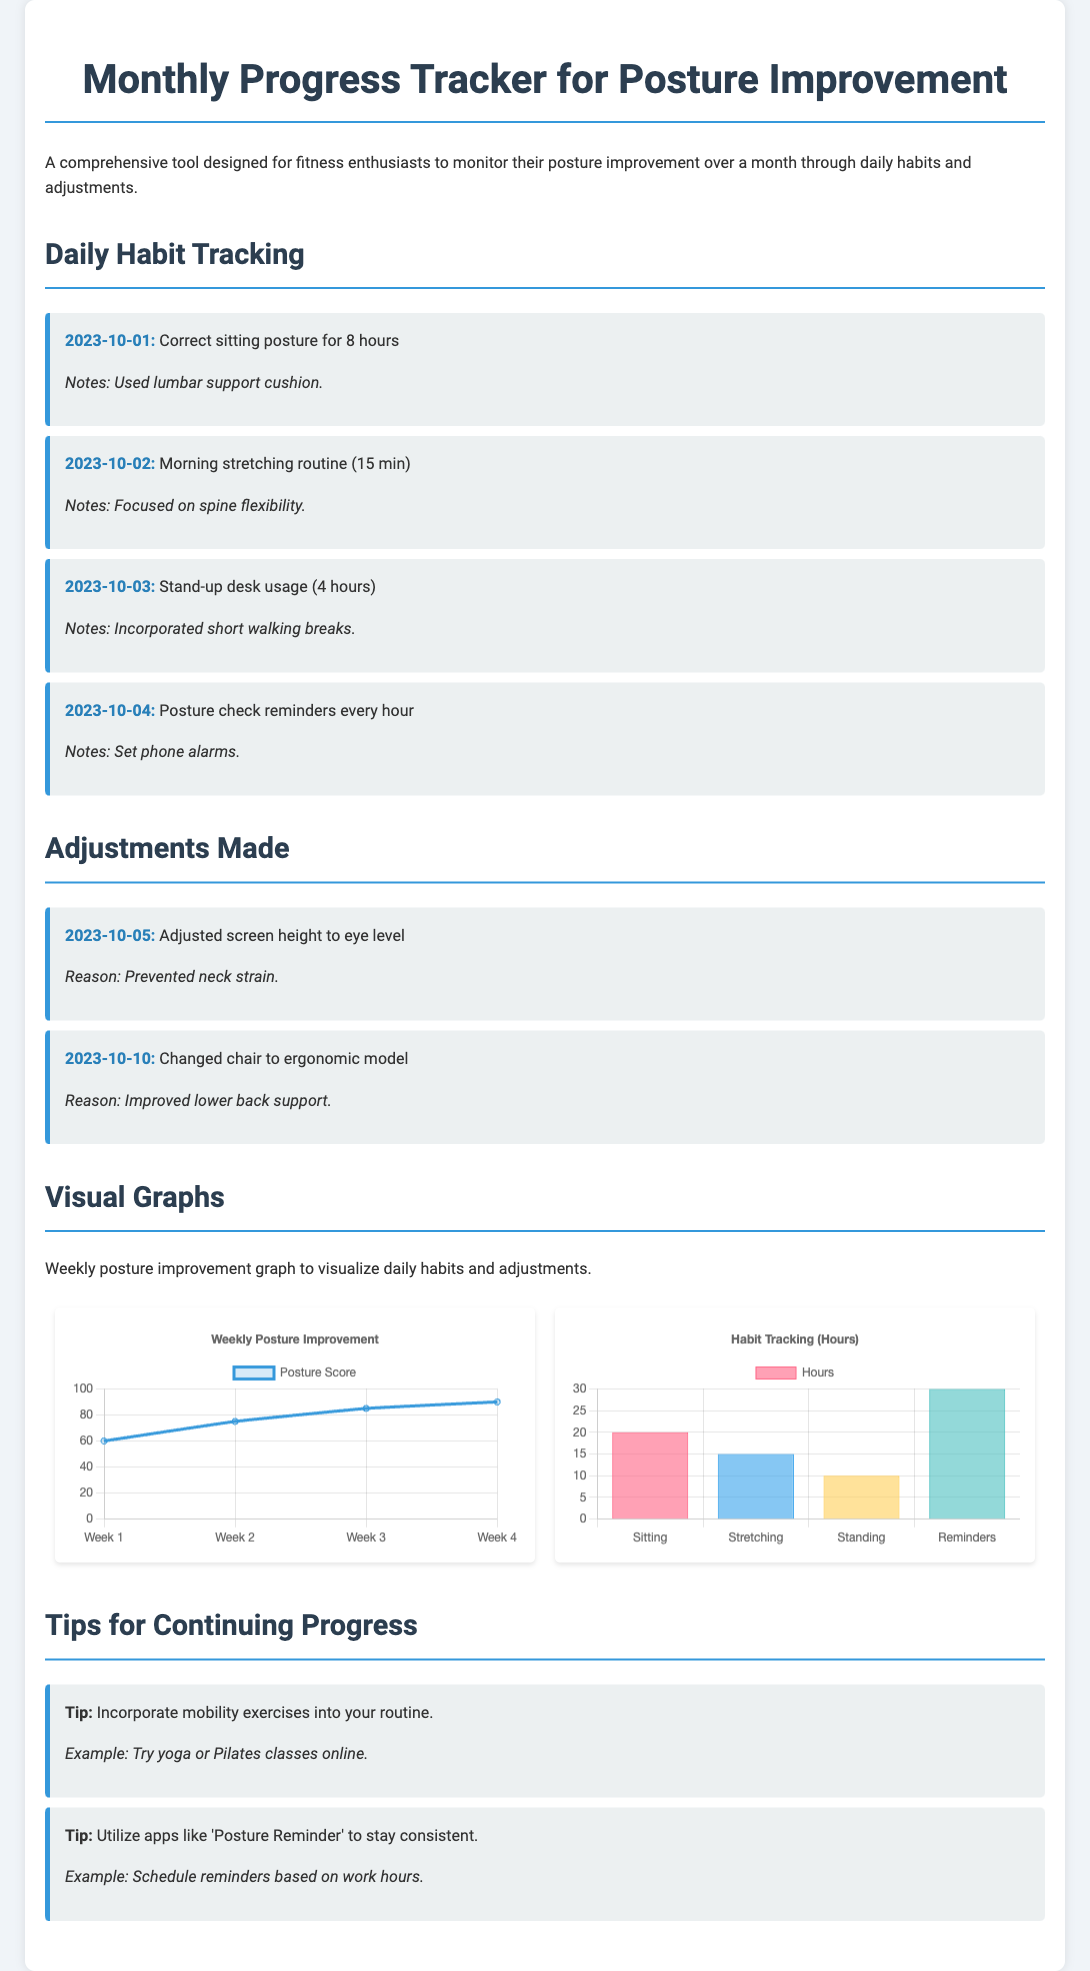what is the title of the document? The title of the document is found at the top, indicating its purpose.
Answer: Monthly Progress Tracker for Posture Improvement how many weeks are displayed in the posture improvement graph? The graph displays data for posture improvement over a specific duration.
Answer: 4 what date is the first entry in the daily habit tracking section? The first entry date shows when the daily habits started being tracked.
Answer: 2023-10-01 what is the highest posture score recorded in the document? The highest score listed in the graph represents the best posture improvement achieved.
Answer: 90 which habit had the highest recorded hours in the habit tracking graph? Analyzing the bar graph reveals which habit was tracked the most in terms of hours.
Answer: Reminders what adjustment was made on October 10th? This date is associated with a specific change mentioned in the adjustments section.
Answer: Changed chair to ergonomic model what type of graph represents the habit tracking data? The document specifies the format used to display the habit tracking information.
Answer: Bar what tip is suggested for continuing progress? A tip provided in the document offers advice on maintaining posture improvement.
Answer: Incorporate mobility exercises into your routine 